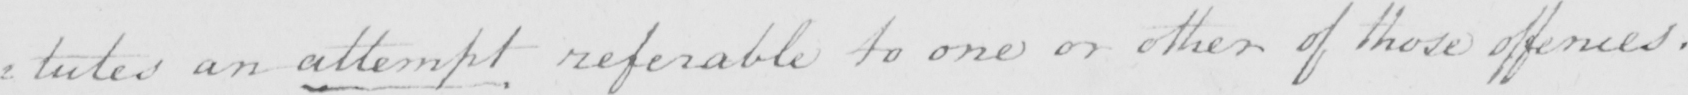What text is written in this handwritten line? : tutes an attempt referable to one or other of these offences . 